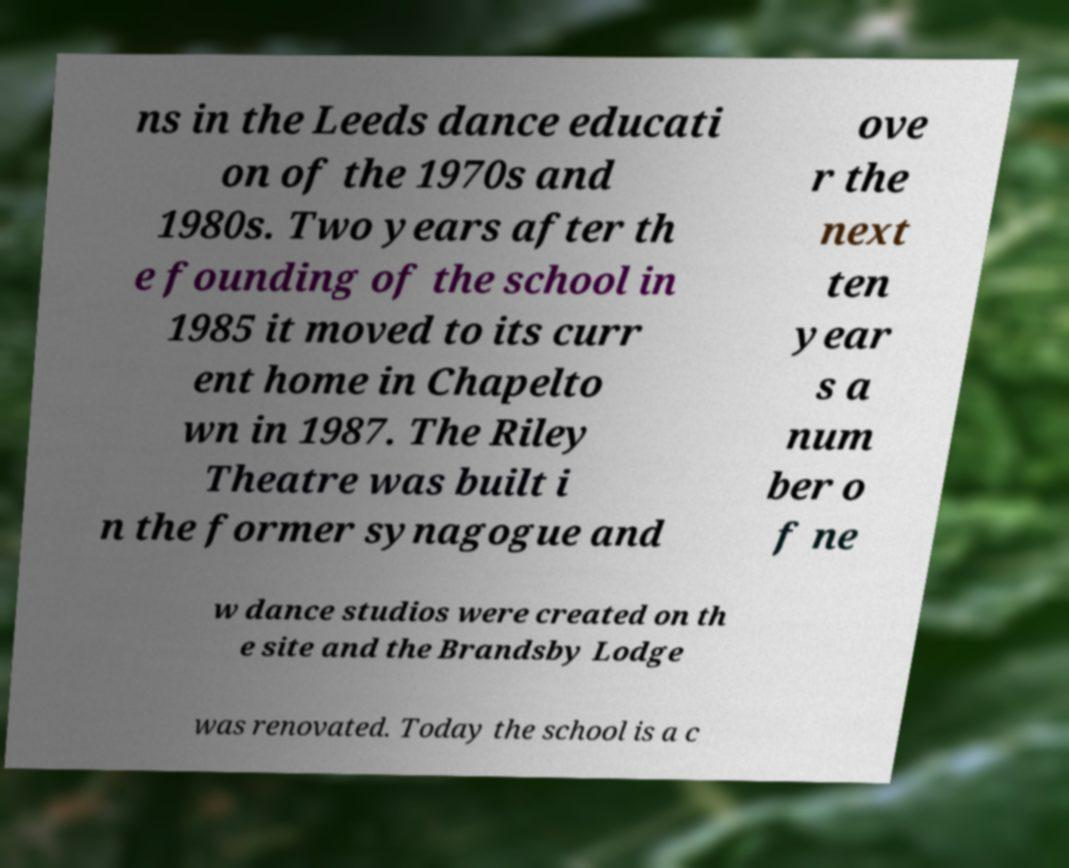Could you extract and type out the text from this image? ns in the Leeds dance educati on of the 1970s and 1980s. Two years after th e founding of the school in 1985 it moved to its curr ent home in Chapelto wn in 1987. The Riley Theatre was built i n the former synagogue and ove r the next ten year s a num ber o f ne w dance studios were created on th e site and the Brandsby Lodge was renovated. Today the school is a c 